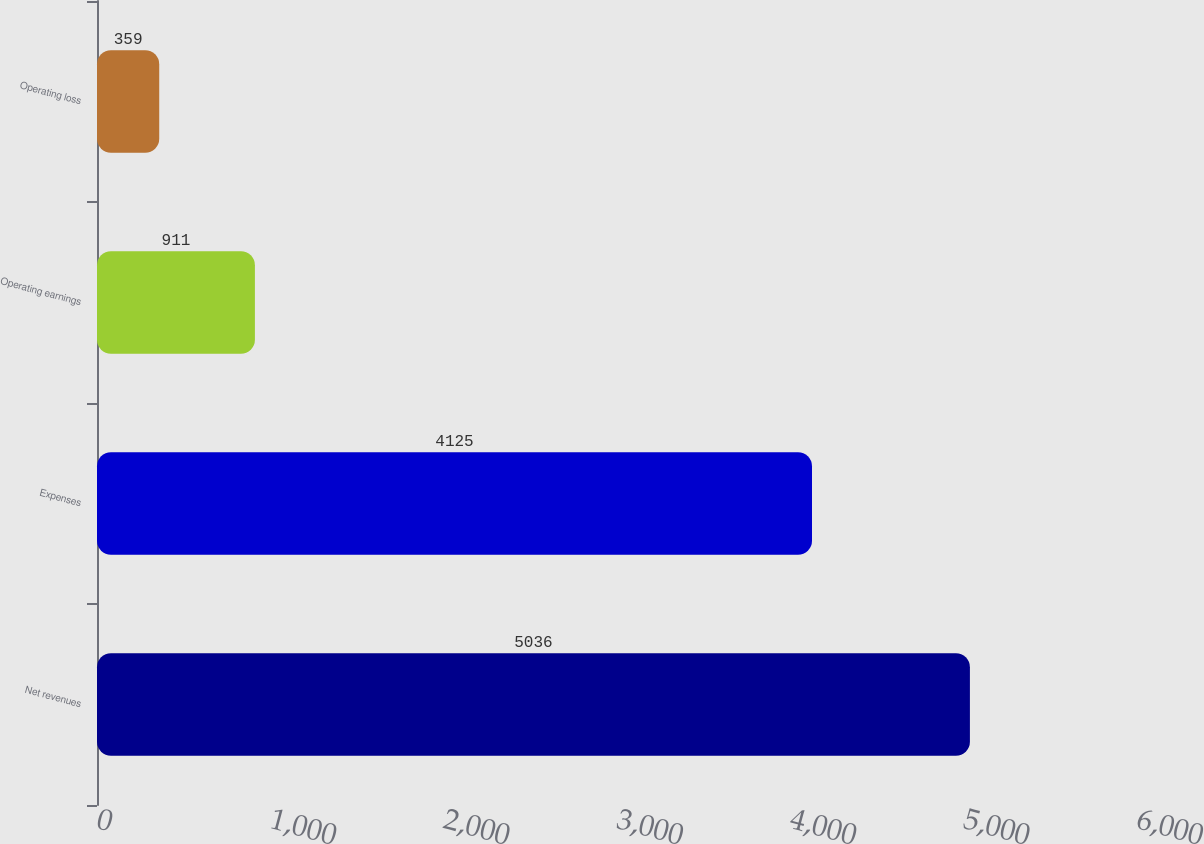Convert chart. <chart><loc_0><loc_0><loc_500><loc_500><bar_chart><fcel>Net revenues<fcel>Expenses<fcel>Operating earnings<fcel>Operating loss<nl><fcel>5036<fcel>4125<fcel>911<fcel>359<nl></chart> 